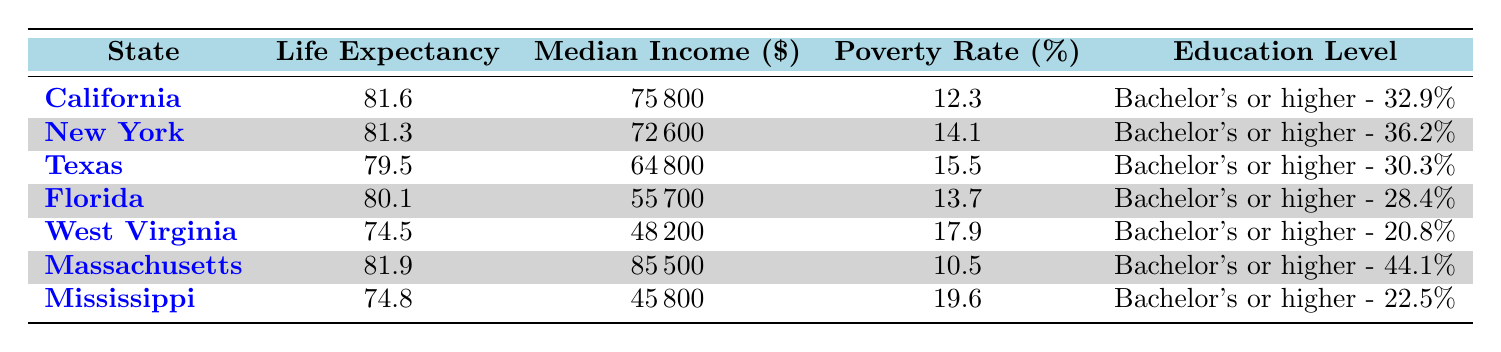What is the average life expectancy in California? According to the table, the average life expectancy in California is listed as 81.6 years.
Answer: 81.6 Which state has the lowest median income? By comparing the median income values, Mississippi has the lowest median income at 45800 dollars.
Answer: Mississippi Is Massachusetts's average life expectancy greater than 80 years? The average life expectancy in Massachusetts is 81.9 years, which is greater than 80. Hence, the statement is true.
Answer: Yes What is the difference in poverty rate between Florida and Texas? The poverty rate for Florida is 13.7 percent and for Texas, it is 15.5 percent. The difference is 15.5 - 13.7 = 1.8 percent.
Answer: 1.8 Which two states have the highest percentage of residents with a bachelor’s degree or higher? By reviewing the education levels, Massachusetts has 44.1 percent and New York has 36.2 percent, making them the two states with the highest percentages.
Answer: Massachusetts and New York Is the average life expectancy in West Virginia above or below 75 years? The average life expectancy in West Virginia is 74.5 years, which is below 75 years.
Answer: Below What is the average median income of California, New York, and Texas combined? Adding the median incomes: 75800 (California) + 72600 (New York) + 64800 (Texas) gives us a total of 213200. Dividing by 3 for the average results in 213200 / 3 ≈ 71066.67.
Answer: Approximately 71066.67 Which state has the highest life expectancy among those listed? Reviewing the life expectancy values, Massachusetts has the highest at 81.9 years.
Answer: Massachusetts What percentage of residents in Mississippi hold a bachelor’s degree or higher? According to the table, the percentage of residents in Mississippi with a bachelor’s degree or higher is 22.5 percent.
Answer: 22.5 